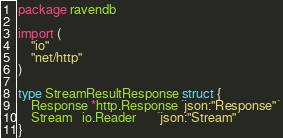<code> <loc_0><loc_0><loc_500><loc_500><_Go_>package ravendb

import (
	"io"
	"net/http"
)

type StreamResultResponse struct {
	Response *http.Response `json:"Response"`
	Stream   io.Reader      `json:"Stream"`
}
</code> 